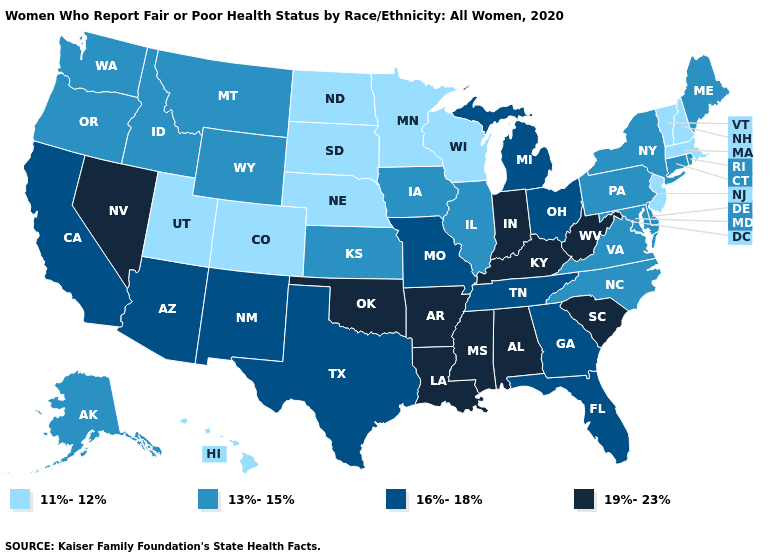Which states have the lowest value in the USA?
Answer briefly. Colorado, Hawaii, Massachusetts, Minnesota, Nebraska, New Hampshire, New Jersey, North Dakota, South Dakota, Utah, Vermont, Wisconsin. Name the states that have a value in the range 16%-18%?
Give a very brief answer. Arizona, California, Florida, Georgia, Michigan, Missouri, New Mexico, Ohio, Tennessee, Texas. Does the map have missing data?
Short answer required. No. What is the value of New Mexico?
Be succinct. 16%-18%. What is the value of Maryland?
Be succinct. 13%-15%. Does the map have missing data?
Give a very brief answer. No. Is the legend a continuous bar?
Keep it brief. No. What is the value of Delaware?
Write a very short answer. 13%-15%. What is the lowest value in the USA?
Quick response, please. 11%-12%. Name the states that have a value in the range 16%-18%?
Quick response, please. Arizona, California, Florida, Georgia, Michigan, Missouri, New Mexico, Ohio, Tennessee, Texas. Which states have the lowest value in the Northeast?
Give a very brief answer. Massachusetts, New Hampshire, New Jersey, Vermont. Name the states that have a value in the range 16%-18%?
Answer briefly. Arizona, California, Florida, Georgia, Michigan, Missouri, New Mexico, Ohio, Tennessee, Texas. Name the states that have a value in the range 19%-23%?
Answer briefly. Alabama, Arkansas, Indiana, Kentucky, Louisiana, Mississippi, Nevada, Oklahoma, South Carolina, West Virginia. Does Idaho have the same value as North Carolina?
Quick response, please. Yes. What is the highest value in states that border Missouri?
Give a very brief answer. 19%-23%. 